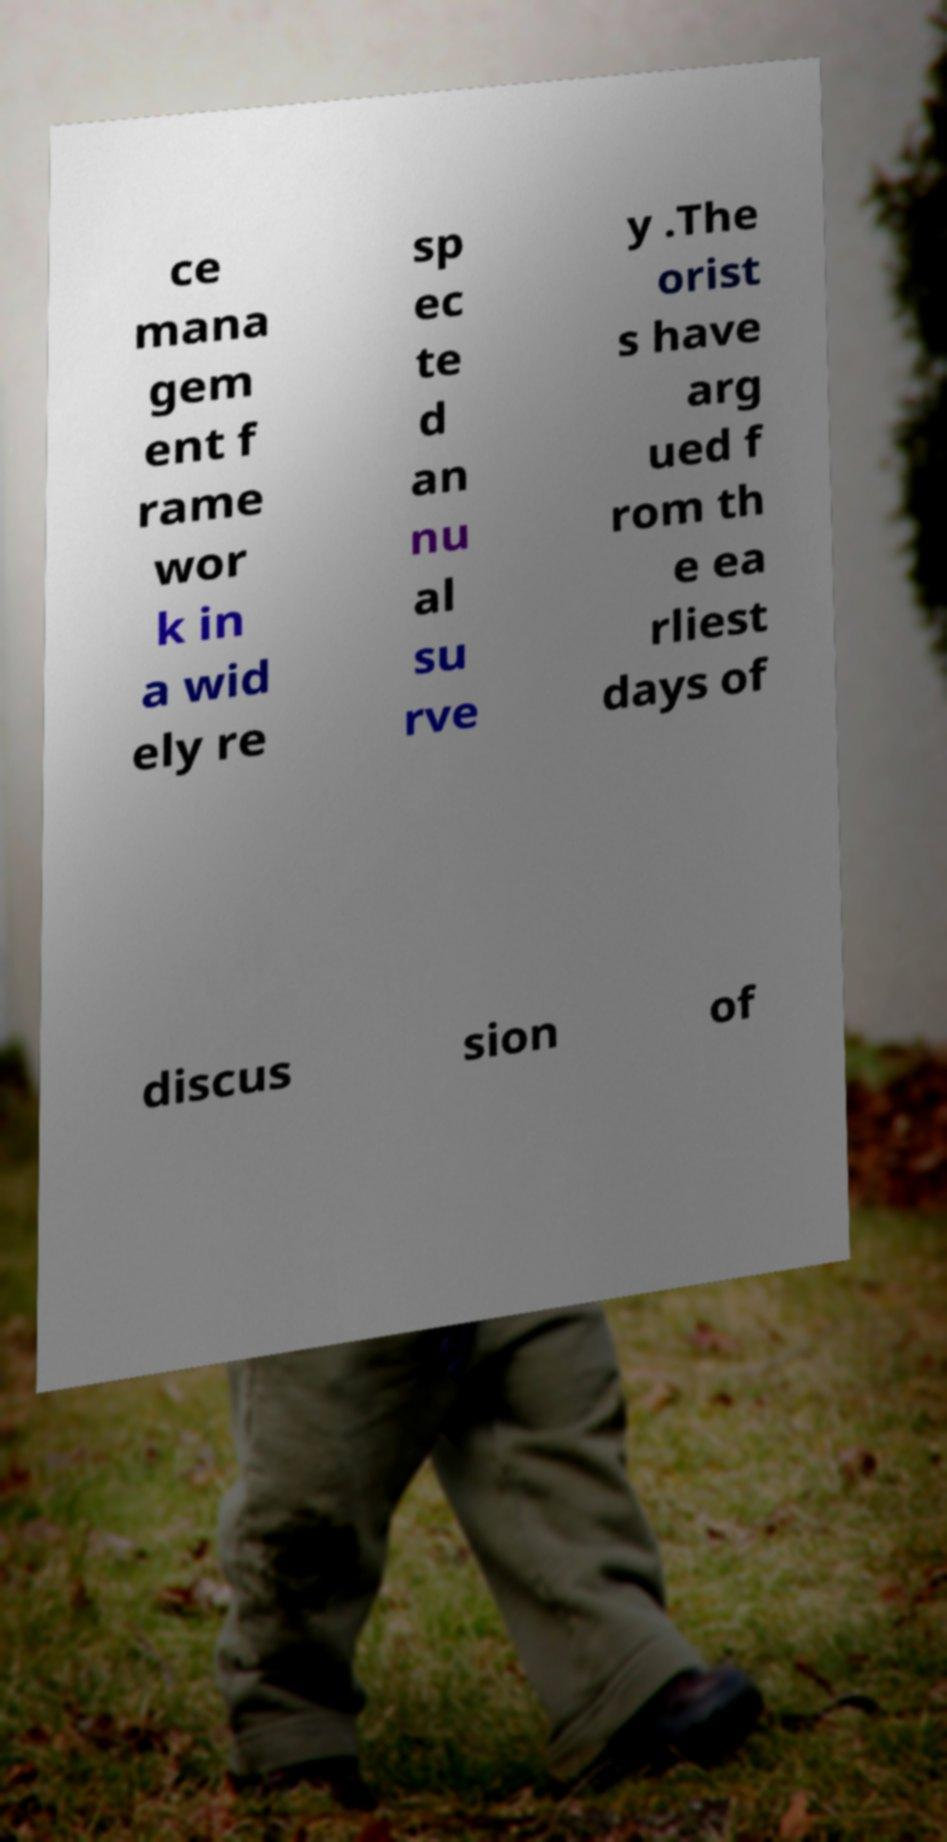I need the written content from this picture converted into text. Can you do that? ce mana gem ent f rame wor k in a wid ely re sp ec te d an nu al su rve y .The orist s have arg ued f rom th e ea rliest days of discus sion of 